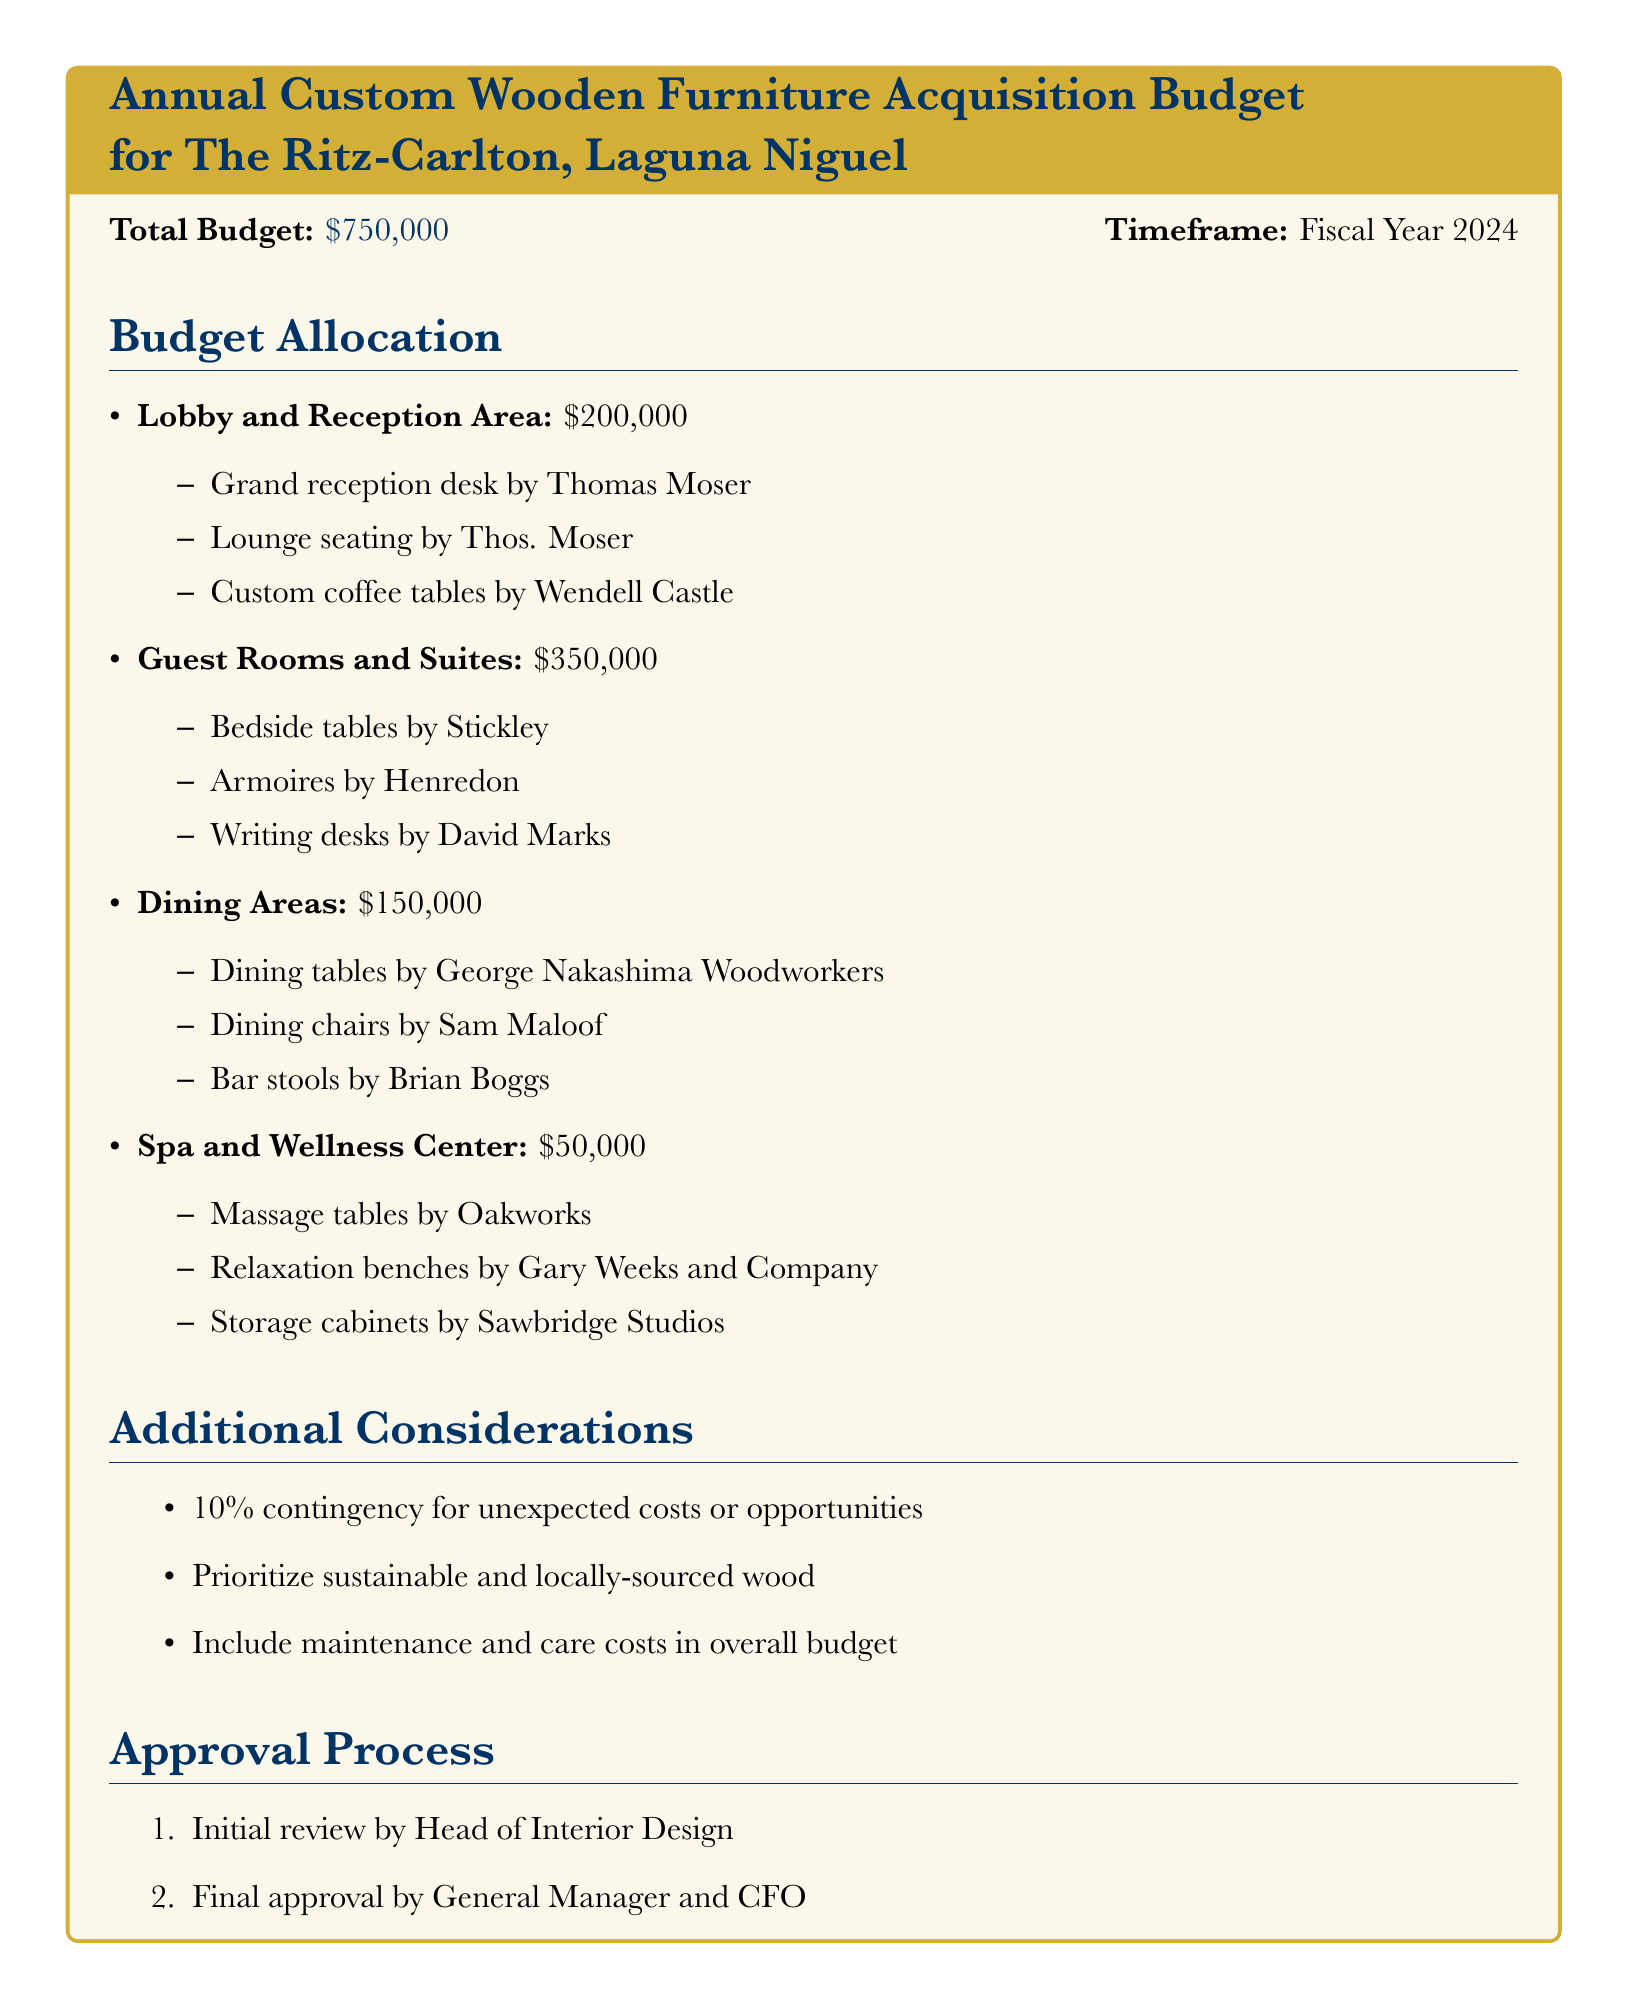What is the total budget for custom wooden furniture acquisitions? The total budget is listed at the top of the document.
Answer: $750,000 How much is allocated for Guest Rooms and Suites? The amount allocated for Guest Rooms and Suites is specified under Budget Allocation.
Answer: $350,000 Who designed the lounge seating for the lobby? The designer of the lounge seating is mentioned in the Lobby and Reception Area section.
Answer: Thos. Moser What percentage of the budget is set aside for contingency? The contingency percentage is noted in the Additional Considerations section.
Answer: 10% What type of furniture will be purchased for the Spa and Wellness Center? The types of furniture are listed under the relevant section of the budget.
Answer: Massage tables, Relaxation benches, Storage cabinets How much is allocated for Dining Areas? The allocation for Dining Areas is clear in the Budget Allocation section.
Answer: $150,000 What is the approval process's first step? The first step in the approval process is outlined in the Approval Process section.
Answer: Initial review by Head of Interior Design Which woodworkers are involved in creating the dining chairs? The name of the woodworker for dining chairs appears in the Dining Areas section.
Answer: Sam Maloof 